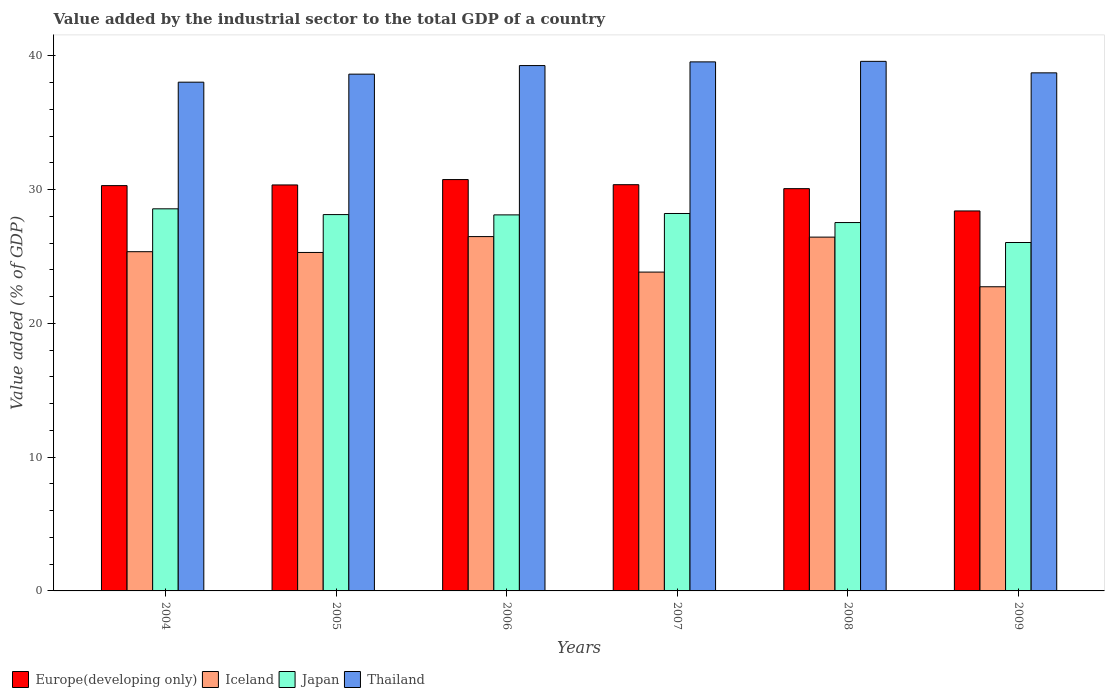How many different coloured bars are there?
Your answer should be compact. 4. How many groups of bars are there?
Provide a short and direct response. 6. Are the number of bars on each tick of the X-axis equal?
Offer a very short reply. Yes. How many bars are there on the 5th tick from the left?
Your answer should be compact. 4. How many bars are there on the 6th tick from the right?
Provide a succinct answer. 4. What is the value added by the industrial sector to the total GDP in Iceland in 2004?
Offer a terse response. 25.36. Across all years, what is the maximum value added by the industrial sector to the total GDP in Japan?
Provide a short and direct response. 28.56. Across all years, what is the minimum value added by the industrial sector to the total GDP in Thailand?
Offer a terse response. 38.03. In which year was the value added by the industrial sector to the total GDP in Iceland maximum?
Give a very brief answer. 2006. What is the total value added by the industrial sector to the total GDP in Japan in the graph?
Provide a short and direct response. 166.6. What is the difference between the value added by the industrial sector to the total GDP in Iceland in 2005 and that in 2008?
Offer a very short reply. -1.15. What is the difference between the value added by the industrial sector to the total GDP in Japan in 2008 and the value added by the industrial sector to the total GDP in Europe(developing only) in 2009?
Keep it short and to the point. -0.87. What is the average value added by the industrial sector to the total GDP in Iceland per year?
Give a very brief answer. 25.03. In the year 2004, what is the difference between the value added by the industrial sector to the total GDP in Thailand and value added by the industrial sector to the total GDP in Japan?
Give a very brief answer. 9.47. In how many years, is the value added by the industrial sector to the total GDP in Japan greater than 6 %?
Offer a terse response. 6. What is the ratio of the value added by the industrial sector to the total GDP in Thailand in 2005 to that in 2007?
Offer a terse response. 0.98. Is the value added by the industrial sector to the total GDP in Japan in 2007 less than that in 2008?
Provide a succinct answer. No. Is the difference between the value added by the industrial sector to the total GDP in Thailand in 2006 and 2008 greater than the difference between the value added by the industrial sector to the total GDP in Japan in 2006 and 2008?
Your response must be concise. No. What is the difference between the highest and the second highest value added by the industrial sector to the total GDP in Iceland?
Ensure brevity in your answer.  0.04. What is the difference between the highest and the lowest value added by the industrial sector to the total GDP in Iceland?
Provide a succinct answer. 3.75. What does the 2nd bar from the right in 2006 represents?
Your answer should be compact. Japan. Is it the case that in every year, the sum of the value added by the industrial sector to the total GDP in Thailand and value added by the industrial sector to the total GDP in Europe(developing only) is greater than the value added by the industrial sector to the total GDP in Japan?
Provide a succinct answer. Yes. How many bars are there?
Provide a short and direct response. 24. Are all the bars in the graph horizontal?
Ensure brevity in your answer.  No. How many years are there in the graph?
Offer a terse response. 6. What is the difference between two consecutive major ticks on the Y-axis?
Give a very brief answer. 10. How many legend labels are there?
Give a very brief answer. 4. What is the title of the graph?
Provide a succinct answer. Value added by the industrial sector to the total GDP of a country. What is the label or title of the X-axis?
Make the answer very short. Years. What is the label or title of the Y-axis?
Keep it short and to the point. Value added (% of GDP). What is the Value added (% of GDP) of Europe(developing only) in 2004?
Keep it short and to the point. 30.3. What is the Value added (% of GDP) of Iceland in 2004?
Your answer should be very brief. 25.36. What is the Value added (% of GDP) of Japan in 2004?
Keep it short and to the point. 28.56. What is the Value added (% of GDP) of Thailand in 2004?
Give a very brief answer. 38.03. What is the Value added (% of GDP) of Europe(developing only) in 2005?
Your answer should be compact. 30.35. What is the Value added (% of GDP) of Iceland in 2005?
Provide a succinct answer. 25.3. What is the Value added (% of GDP) of Japan in 2005?
Offer a very short reply. 28.13. What is the Value added (% of GDP) of Thailand in 2005?
Give a very brief answer. 38.63. What is the Value added (% of GDP) in Europe(developing only) in 2006?
Your answer should be very brief. 30.75. What is the Value added (% of GDP) in Iceland in 2006?
Your response must be concise. 26.49. What is the Value added (% of GDP) of Japan in 2006?
Your answer should be compact. 28.11. What is the Value added (% of GDP) in Thailand in 2006?
Your answer should be compact. 39.27. What is the Value added (% of GDP) of Europe(developing only) in 2007?
Provide a succinct answer. 30.37. What is the Value added (% of GDP) in Iceland in 2007?
Make the answer very short. 23.83. What is the Value added (% of GDP) of Japan in 2007?
Provide a short and direct response. 28.21. What is the Value added (% of GDP) of Thailand in 2007?
Provide a short and direct response. 39.55. What is the Value added (% of GDP) in Europe(developing only) in 2008?
Give a very brief answer. 30.07. What is the Value added (% of GDP) in Iceland in 2008?
Your response must be concise. 26.45. What is the Value added (% of GDP) of Japan in 2008?
Keep it short and to the point. 27.54. What is the Value added (% of GDP) in Thailand in 2008?
Your answer should be very brief. 39.59. What is the Value added (% of GDP) in Europe(developing only) in 2009?
Make the answer very short. 28.4. What is the Value added (% of GDP) of Iceland in 2009?
Your response must be concise. 22.74. What is the Value added (% of GDP) in Japan in 2009?
Ensure brevity in your answer.  26.04. What is the Value added (% of GDP) of Thailand in 2009?
Your answer should be very brief. 38.73. Across all years, what is the maximum Value added (% of GDP) in Europe(developing only)?
Give a very brief answer. 30.75. Across all years, what is the maximum Value added (% of GDP) of Iceland?
Offer a terse response. 26.49. Across all years, what is the maximum Value added (% of GDP) of Japan?
Offer a terse response. 28.56. Across all years, what is the maximum Value added (% of GDP) of Thailand?
Your answer should be compact. 39.59. Across all years, what is the minimum Value added (% of GDP) of Europe(developing only)?
Keep it short and to the point. 28.4. Across all years, what is the minimum Value added (% of GDP) of Iceland?
Offer a very short reply. 22.74. Across all years, what is the minimum Value added (% of GDP) of Japan?
Provide a succinct answer. 26.04. Across all years, what is the minimum Value added (% of GDP) of Thailand?
Provide a succinct answer. 38.03. What is the total Value added (% of GDP) in Europe(developing only) in the graph?
Provide a succinct answer. 180.23. What is the total Value added (% of GDP) of Iceland in the graph?
Your answer should be compact. 150.16. What is the total Value added (% of GDP) in Japan in the graph?
Ensure brevity in your answer.  166.6. What is the total Value added (% of GDP) in Thailand in the graph?
Make the answer very short. 233.78. What is the difference between the Value added (% of GDP) of Europe(developing only) in 2004 and that in 2005?
Offer a terse response. -0.05. What is the difference between the Value added (% of GDP) in Iceland in 2004 and that in 2005?
Ensure brevity in your answer.  0.06. What is the difference between the Value added (% of GDP) of Japan in 2004 and that in 2005?
Offer a terse response. 0.43. What is the difference between the Value added (% of GDP) of Thailand in 2004 and that in 2005?
Your response must be concise. -0.6. What is the difference between the Value added (% of GDP) in Europe(developing only) in 2004 and that in 2006?
Give a very brief answer. -0.45. What is the difference between the Value added (% of GDP) in Iceland in 2004 and that in 2006?
Provide a succinct answer. -1.13. What is the difference between the Value added (% of GDP) of Japan in 2004 and that in 2006?
Offer a terse response. 0.45. What is the difference between the Value added (% of GDP) in Thailand in 2004 and that in 2006?
Keep it short and to the point. -1.24. What is the difference between the Value added (% of GDP) of Europe(developing only) in 2004 and that in 2007?
Your answer should be compact. -0.07. What is the difference between the Value added (% of GDP) of Iceland in 2004 and that in 2007?
Your answer should be compact. 1.52. What is the difference between the Value added (% of GDP) of Japan in 2004 and that in 2007?
Provide a succinct answer. 0.35. What is the difference between the Value added (% of GDP) of Thailand in 2004 and that in 2007?
Ensure brevity in your answer.  -1.52. What is the difference between the Value added (% of GDP) of Europe(developing only) in 2004 and that in 2008?
Make the answer very short. 0.23. What is the difference between the Value added (% of GDP) in Iceland in 2004 and that in 2008?
Offer a very short reply. -1.09. What is the difference between the Value added (% of GDP) of Japan in 2004 and that in 2008?
Offer a terse response. 1.03. What is the difference between the Value added (% of GDP) of Thailand in 2004 and that in 2008?
Your answer should be very brief. -1.56. What is the difference between the Value added (% of GDP) of Europe(developing only) in 2004 and that in 2009?
Ensure brevity in your answer.  1.89. What is the difference between the Value added (% of GDP) in Iceland in 2004 and that in 2009?
Ensure brevity in your answer.  2.62. What is the difference between the Value added (% of GDP) of Japan in 2004 and that in 2009?
Your response must be concise. 2.52. What is the difference between the Value added (% of GDP) in Thailand in 2004 and that in 2009?
Make the answer very short. -0.7. What is the difference between the Value added (% of GDP) of Europe(developing only) in 2005 and that in 2006?
Give a very brief answer. -0.4. What is the difference between the Value added (% of GDP) in Iceland in 2005 and that in 2006?
Offer a terse response. -1.19. What is the difference between the Value added (% of GDP) of Japan in 2005 and that in 2006?
Your answer should be compact. 0.02. What is the difference between the Value added (% of GDP) in Thailand in 2005 and that in 2006?
Provide a succinct answer. -0.64. What is the difference between the Value added (% of GDP) of Europe(developing only) in 2005 and that in 2007?
Offer a very short reply. -0.02. What is the difference between the Value added (% of GDP) in Iceland in 2005 and that in 2007?
Ensure brevity in your answer.  1.47. What is the difference between the Value added (% of GDP) of Japan in 2005 and that in 2007?
Keep it short and to the point. -0.08. What is the difference between the Value added (% of GDP) in Thailand in 2005 and that in 2007?
Offer a very short reply. -0.92. What is the difference between the Value added (% of GDP) in Europe(developing only) in 2005 and that in 2008?
Provide a short and direct response. 0.28. What is the difference between the Value added (% of GDP) in Iceland in 2005 and that in 2008?
Give a very brief answer. -1.15. What is the difference between the Value added (% of GDP) of Japan in 2005 and that in 2008?
Offer a very short reply. 0.6. What is the difference between the Value added (% of GDP) in Thailand in 2005 and that in 2008?
Ensure brevity in your answer.  -0.96. What is the difference between the Value added (% of GDP) of Europe(developing only) in 2005 and that in 2009?
Your answer should be very brief. 1.94. What is the difference between the Value added (% of GDP) of Iceland in 2005 and that in 2009?
Your answer should be compact. 2.56. What is the difference between the Value added (% of GDP) of Japan in 2005 and that in 2009?
Your answer should be very brief. 2.09. What is the difference between the Value added (% of GDP) in Thailand in 2005 and that in 2009?
Offer a terse response. -0.1. What is the difference between the Value added (% of GDP) of Europe(developing only) in 2006 and that in 2007?
Your answer should be compact. 0.38. What is the difference between the Value added (% of GDP) of Iceland in 2006 and that in 2007?
Provide a succinct answer. 2.65. What is the difference between the Value added (% of GDP) of Japan in 2006 and that in 2007?
Provide a short and direct response. -0.1. What is the difference between the Value added (% of GDP) of Thailand in 2006 and that in 2007?
Offer a very short reply. -0.28. What is the difference between the Value added (% of GDP) of Europe(developing only) in 2006 and that in 2008?
Provide a short and direct response. 0.68. What is the difference between the Value added (% of GDP) of Iceland in 2006 and that in 2008?
Offer a terse response. 0.04. What is the difference between the Value added (% of GDP) of Japan in 2006 and that in 2008?
Keep it short and to the point. 0.57. What is the difference between the Value added (% of GDP) in Thailand in 2006 and that in 2008?
Your response must be concise. -0.32. What is the difference between the Value added (% of GDP) in Europe(developing only) in 2006 and that in 2009?
Give a very brief answer. 2.35. What is the difference between the Value added (% of GDP) of Iceland in 2006 and that in 2009?
Offer a terse response. 3.75. What is the difference between the Value added (% of GDP) in Japan in 2006 and that in 2009?
Keep it short and to the point. 2.06. What is the difference between the Value added (% of GDP) in Thailand in 2006 and that in 2009?
Offer a very short reply. 0.54. What is the difference between the Value added (% of GDP) of Europe(developing only) in 2007 and that in 2008?
Ensure brevity in your answer.  0.3. What is the difference between the Value added (% of GDP) in Iceland in 2007 and that in 2008?
Ensure brevity in your answer.  -2.61. What is the difference between the Value added (% of GDP) of Japan in 2007 and that in 2008?
Your answer should be compact. 0.68. What is the difference between the Value added (% of GDP) in Thailand in 2007 and that in 2008?
Offer a very short reply. -0.04. What is the difference between the Value added (% of GDP) in Europe(developing only) in 2007 and that in 2009?
Provide a succinct answer. 1.96. What is the difference between the Value added (% of GDP) of Iceland in 2007 and that in 2009?
Your answer should be very brief. 1.1. What is the difference between the Value added (% of GDP) of Japan in 2007 and that in 2009?
Ensure brevity in your answer.  2.17. What is the difference between the Value added (% of GDP) in Thailand in 2007 and that in 2009?
Offer a terse response. 0.82. What is the difference between the Value added (% of GDP) of Europe(developing only) in 2008 and that in 2009?
Ensure brevity in your answer.  1.67. What is the difference between the Value added (% of GDP) in Iceland in 2008 and that in 2009?
Offer a terse response. 3.71. What is the difference between the Value added (% of GDP) in Japan in 2008 and that in 2009?
Your answer should be very brief. 1.49. What is the difference between the Value added (% of GDP) of Thailand in 2008 and that in 2009?
Offer a terse response. 0.86. What is the difference between the Value added (% of GDP) of Europe(developing only) in 2004 and the Value added (% of GDP) of Iceland in 2005?
Offer a terse response. 5. What is the difference between the Value added (% of GDP) in Europe(developing only) in 2004 and the Value added (% of GDP) in Japan in 2005?
Keep it short and to the point. 2.17. What is the difference between the Value added (% of GDP) in Europe(developing only) in 2004 and the Value added (% of GDP) in Thailand in 2005?
Ensure brevity in your answer.  -8.33. What is the difference between the Value added (% of GDP) in Iceland in 2004 and the Value added (% of GDP) in Japan in 2005?
Provide a short and direct response. -2.77. What is the difference between the Value added (% of GDP) in Iceland in 2004 and the Value added (% of GDP) in Thailand in 2005?
Give a very brief answer. -13.27. What is the difference between the Value added (% of GDP) of Japan in 2004 and the Value added (% of GDP) of Thailand in 2005?
Your answer should be very brief. -10.07. What is the difference between the Value added (% of GDP) in Europe(developing only) in 2004 and the Value added (% of GDP) in Iceland in 2006?
Offer a very short reply. 3.81. What is the difference between the Value added (% of GDP) of Europe(developing only) in 2004 and the Value added (% of GDP) of Japan in 2006?
Your answer should be very brief. 2.19. What is the difference between the Value added (% of GDP) in Europe(developing only) in 2004 and the Value added (% of GDP) in Thailand in 2006?
Offer a terse response. -8.97. What is the difference between the Value added (% of GDP) of Iceland in 2004 and the Value added (% of GDP) of Japan in 2006?
Offer a terse response. -2.75. What is the difference between the Value added (% of GDP) in Iceland in 2004 and the Value added (% of GDP) in Thailand in 2006?
Your response must be concise. -13.91. What is the difference between the Value added (% of GDP) of Japan in 2004 and the Value added (% of GDP) of Thailand in 2006?
Give a very brief answer. -10.71. What is the difference between the Value added (% of GDP) of Europe(developing only) in 2004 and the Value added (% of GDP) of Iceland in 2007?
Give a very brief answer. 6.46. What is the difference between the Value added (% of GDP) of Europe(developing only) in 2004 and the Value added (% of GDP) of Japan in 2007?
Keep it short and to the point. 2.08. What is the difference between the Value added (% of GDP) in Europe(developing only) in 2004 and the Value added (% of GDP) in Thailand in 2007?
Provide a succinct answer. -9.25. What is the difference between the Value added (% of GDP) of Iceland in 2004 and the Value added (% of GDP) of Japan in 2007?
Make the answer very short. -2.86. What is the difference between the Value added (% of GDP) of Iceland in 2004 and the Value added (% of GDP) of Thailand in 2007?
Give a very brief answer. -14.19. What is the difference between the Value added (% of GDP) of Japan in 2004 and the Value added (% of GDP) of Thailand in 2007?
Your answer should be very brief. -10.98. What is the difference between the Value added (% of GDP) in Europe(developing only) in 2004 and the Value added (% of GDP) in Iceland in 2008?
Your answer should be very brief. 3.85. What is the difference between the Value added (% of GDP) in Europe(developing only) in 2004 and the Value added (% of GDP) in Japan in 2008?
Your answer should be very brief. 2.76. What is the difference between the Value added (% of GDP) in Europe(developing only) in 2004 and the Value added (% of GDP) in Thailand in 2008?
Your answer should be compact. -9.29. What is the difference between the Value added (% of GDP) of Iceland in 2004 and the Value added (% of GDP) of Japan in 2008?
Offer a terse response. -2.18. What is the difference between the Value added (% of GDP) of Iceland in 2004 and the Value added (% of GDP) of Thailand in 2008?
Ensure brevity in your answer.  -14.23. What is the difference between the Value added (% of GDP) in Japan in 2004 and the Value added (% of GDP) in Thailand in 2008?
Make the answer very short. -11.02. What is the difference between the Value added (% of GDP) of Europe(developing only) in 2004 and the Value added (% of GDP) of Iceland in 2009?
Offer a very short reply. 7.56. What is the difference between the Value added (% of GDP) in Europe(developing only) in 2004 and the Value added (% of GDP) in Japan in 2009?
Make the answer very short. 4.25. What is the difference between the Value added (% of GDP) in Europe(developing only) in 2004 and the Value added (% of GDP) in Thailand in 2009?
Offer a terse response. -8.43. What is the difference between the Value added (% of GDP) of Iceland in 2004 and the Value added (% of GDP) of Japan in 2009?
Give a very brief answer. -0.69. What is the difference between the Value added (% of GDP) of Iceland in 2004 and the Value added (% of GDP) of Thailand in 2009?
Your answer should be compact. -13.37. What is the difference between the Value added (% of GDP) in Japan in 2004 and the Value added (% of GDP) in Thailand in 2009?
Keep it short and to the point. -10.16. What is the difference between the Value added (% of GDP) of Europe(developing only) in 2005 and the Value added (% of GDP) of Iceland in 2006?
Give a very brief answer. 3.86. What is the difference between the Value added (% of GDP) in Europe(developing only) in 2005 and the Value added (% of GDP) in Japan in 2006?
Ensure brevity in your answer.  2.24. What is the difference between the Value added (% of GDP) in Europe(developing only) in 2005 and the Value added (% of GDP) in Thailand in 2006?
Your answer should be very brief. -8.92. What is the difference between the Value added (% of GDP) in Iceland in 2005 and the Value added (% of GDP) in Japan in 2006?
Provide a short and direct response. -2.81. What is the difference between the Value added (% of GDP) of Iceland in 2005 and the Value added (% of GDP) of Thailand in 2006?
Keep it short and to the point. -13.97. What is the difference between the Value added (% of GDP) in Japan in 2005 and the Value added (% of GDP) in Thailand in 2006?
Offer a terse response. -11.14. What is the difference between the Value added (% of GDP) in Europe(developing only) in 2005 and the Value added (% of GDP) in Iceland in 2007?
Make the answer very short. 6.51. What is the difference between the Value added (% of GDP) of Europe(developing only) in 2005 and the Value added (% of GDP) of Japan in 2007?
Ensure brevity in your answer.  2.13. What is the difference between the Value added (% of GDP) in Europe(developing only) in 2005 and the Value added (% of GDP) in Thailand in 2007?
Offer a very short reply. -9.2. What is the difference between the Value added (% of GDP) in Iceland in 2005 and the Value added (% of GDP) in Japan in 2007?
Provide a short and direct response. -2.91. What is the difference between the Value added (% of GDP) of Iceland in 2005 and the Value added (% of GDP) of Thailand in 2007?
Keep it short and to the point. -14.25. What is the difference between the Value added (% of GDP) of Japan in 2005 and the Value added (% of GDP) of Thailand in 2007?
Provide a succinct answer. -11.41. What is the difference between the Value added (% of GDP) of Europe(developing only) in 2005 and the Value added (% of GDP) of Iceland in 2008?
Give a very brief answer. 3.9. What is the difference between the Value added (% of GDP) in Europe(developing only) in 2005 and the Value added (% of GDP) in Japan in 2008?
Provide a succinct answer. 2.81. What is the difference between the Value added (% of GDP) of Europe(developing only) in 2005 and the Value added (% of GDP) of Thailand in 2008?
Your answer should be compact. -9.24. What is the difference between the Value added (% of GDP) in Iceland in 2005 and the Value added (% of GDP) in Japan in 2008?
Keep it short and to the point. -2.24. What is the difference between the Value added (% of GDP) of Iceland in 2005 and the Value added (% of GDP) of Thailand in 2008?
Provide a short and direct response. -14.29. What is the difference between the Value added (% of GDP) in Japan in 2005 and the Value added (% of GDP) in Thailand in 2008?
Keep it short and to the point. -11.45. What is the difference between the Value added (% of GDP) of Europe(developing only) in 2005 and the Value added (% of GDP) of Iceland in 2009?
Keep it short and to the point. 7.61. What is the difference between the Value added (% of GDP) in Europe(developing only) in 2005 and the Value added (% of GDP) in Japan in 2009?
Your response must be concise. 4.3. What is the difference between the Value added (% of GDP) of Europe(developing only) in 2005 and the Value added (% of GDP) of Thailand in 2009?
Provide a succinct answer. -8.38. What is the difference between the Value added (% of GDP) in Iceland in 2005 and the Value added (% of GDP) in Japan in 2009?
Your answer should be compact. -0.74. What is the difference between the Value added (% of GDP) of Iceland in 2005 and the Value added (% of GDP) of Thailand in 2009?
Your answer should be very brief. -13.43. What is the difference between the Value added (% of GDP) in Japan in 2005 and the Value added (% of GDP) in Thailand in 2009?
Make the answer very short. -10.59. What is the difference between the Value added (% of GDP) of Europe(developing only) in 2006 and the Value added (% of GDP) of Iceland in 2007?
Give a very brief answer. 6.92. What is the difference between the Value added (% of GDP) in Europe(developing only) in 2006 and the Value added (% of GDP) in Japan in 2007?
Offer a terse response. 2.54. What is the difference between the Value added (% of GDP) of Europe(developing only) in 2006 and the Value added (% of GDP) of Thailand in 2007?
Ensure brevity in your answer.  -8.8. What is the difference between the Value added (% of GDP) in Iceland in 2006 and the Value added (% of GDP) in Japan in 2007?
Your response must be concise. -1.73. What is the difference between the Value added (% of GDP) in Iceland in 2006 and the Value added (% of GDP) in Thailand in 2007?
Your answer should be compact. -13.06. What is the difference between the Value added (% of GDP) in Japan in 2006 and the Value added (% of GDP) in Thailand in 2007?
Your answer should be compact. -11.44. What is the difference between the Value added (% of GDP) in Europe(developing only) in 2006 and the Value added (% of GDP) in Iceland in 2008?
Offer a terse response. 4.3. What is the difference between the Value added (% of GDP) of Europe(developing only) in 2006 and the Value added (% of GDP) of Japan in 2008?
Provide a short and direct response. 3.21. What is the difference between the Value added (% of GDP) of Europe(developing only) in 2006 and the Value added (% of GDP) of Thailand in 2008?
Your answer should be very brief. -8.84. What is the difference between the Value added (% of GDP) in Iceland in 2006 and the Value added (% of GDP) in Japan in 2008?
Ensure brevity in your answer.  -1.05. What is the difference between the Value added (% of GDP) in Iceland in 2006 and the Value added (% of GDP) in Thailand in 2008?
Keep it short and to the point. -13.1. What is the difference between the Value added (% of GDP) in Japan in 2006 and the Value added (% of GDP) in Thailand in 2008?
Your answer should be very brief. -11.48. What is the difference between the Value added (% of GDP) of Europe(developing only) in 2006 and the Value added (% of GDP) of Iceland in 2009?
Offer a very short reply. 8.01. What is the difference between the Value added (% of GDP) of Europe(developing only) in 2006 and the Value added (% of GDP) of Japan in 2009?
Offer a terse response. 4.7. What is the difference between the Value added (% of GDP) in Europe(developing only) in 2006 and the Value added (% of GDP) in Thailand in 2009?
Ensure brevity in your answer.  -7.98. What is the difference between the Value added (% of GDP) in Iceland in 2006 and the Value added (% of GDP) in Japan in 2009?
Provide a short and direct response. 0.44. What is the difference between the Value added (% of GDP) of Iceland in 2006 and the Value added (% of GDP) of Thailand in 2009?
Offer a terse response. -12.24. What is the difference between the Value added (% of GDP) of Japan in 2006 and the Value added (% of GDP) of Thailand in 2009?
Offer a terse response. -10.62. What is the difference between the Value added (% of GDP) of Europe(developing only) in 2007 and the Value added (% of GDP) of Iceland in 2008?
Provide a succinct answer. 3.92. What is the difference between the Value added (% of GDP) in Europe(developing only) in 2007 and the Value added (% of GDP) in Japan in 2008?
Offer a terse response. 2.83. What is the difference between the Value added (% of GDP) of Europe(developing only) in 2007 and the Value added (% of GDP) of Thailand in 2008?
Give a very brief answer. -9.22. What is the difference between the Value added (% of GDP) in Iceland in 2007 and the Value added (% of GDP) in Japan in 2008?
Provide a succinct answer. -3.7. What is the difference between the Value added (% of GDP) in Iceland in 2007 and the Value added (% of GDP) in Thailand in 2008?
Your response must be concise. -15.75. What is the difference between the Value added (% of GDP) of Japan in 2007 and the Value added (% of GDP) of Thailand in 2008?
Offer a terse response. -11.37. What is the difference between the Value added (% of GDP) of Europe(developing only) in 2007 and the Value added (% of GDP) of Iceland in 2009?
Offer a terse response. 7.63. What is the difference between the Value added (% of GDP) in Europe(developing only) in 2007 and the Value added (% of GDP) in Japan in 2009?
Ensure brevity in your answer.  4.32. What is the difference between the Value added (% of GDP) in Europe(developing only) in 2007 and the Value added (% of GDP) in Thailand in 2009?
Your answer should be compact. -8.36. What is the difference between the Value added (% of GDP) in Iceland in 2007 and the Value added (% of GDP) in Japan in 2009?
Your answer should be very brief. -2.21. What is the difference between the Value added (% of GDP) in Iceland in 2007 and the Value added (% of GDP) in Thailand in 2009?
Offer a terse response. -14.89. What is the difference between the Value added (% of GDP) in Japan in 2007 and the Value added (% of GDP) in Thailand in 2009?
Keep it short and to the point. -10.51. What is the difference between the Value added (% of GDP) of Europe(developing only) in 2008 and the Value added (% of GDP) of Iceland in 2009?
Offer a very short reply. 7.33. What is the difference between the Value added (% of GDP) in Europe(developing only) in 2008 and the Value added (% of GDP) in Japan in 2009?
Offer a terse response. 4.03. What is the difference between the Value added (% of GDP) in Europe(developing only) in 2008 and the Value added (% of GDP) in Thailand in 2009?
Make the answer very short. -8.66. What is the difference between the Value added (% of GDP) in Iceland in 2008 and the Value added (% of GDP) in Japan in 2009?
Ensure brevity in your answer.  0.4. What is the difference between the Value added (% of GDP) of Iceland in 2008 and the Value added (% of GDP) of Thailand in 2009?
Make the answer very short. -12.28. What is the difference between the Value added (% of GDP) in Japan in 2008 and the Value added (% of GDP) in Thailand in 2009?
Ensure brevity in your answer.  -11.19. What is the average Value added (% of GDP) of Europe(developing only) per year?
Your response must be concise. 30.04. What is the average Value added (% of GDP) in Iceland per year?
Your answer should be compact. 25.03. What is the average Value added (% of GDP) of Japan per year?
Your answer should be very brief. 27.77. What is the average Value added (% of GDP) of Thailand per year?
Provide a short and direct response. 38.96. In the year 2004, what is the difference between the Value added (% of GDP) of Europe(developing only) and Value added (% of GDP) of Iceland?
Ensure brevity in your answer.  4.94. In the year 2004, what is the difference between the Value added (% of GDP) of Europe(developing only) and Value added (% of GDP) of Japan?
Offer a very short reply. 1.73. In the year 2004, what is the difference between the Value added (% of GDP) in Europe(developing only) and Value added (% of GDP) in Thailand?
Your answer should be very brief. -7.73. In the year 2004, what is the difference between the Value added (% of GDP) of Iceland and Value added (% of GDP) of Japan?
Provide a short and direct response. -3.21. In the year 2004, what is the difference between the Value added (% of GDP) in Iceland and Value added (% of GDP) in Thailand?
Provide a short and direct response. -12.67. In the year 2004, what is the difference between the Value added (% of GDP) of Japan and Value added (% of GDP) of Thailand?
Make the answer very short. -9.47. In the year 2005, what is the difference between the Value added (% of GDP) in Europe(developing only) and Value added (% of GDP) in Iceland?
Provide a short and direct response. 5.05. In the year 2005, what is the difference between the Value added (% of GDP) in Europe(developing only) and Value added (% of GDP) in Japan?
Your answer should be very brief. 2.22. In the year 2005, what is the difference between the Value added (% of GDP) in Europe(developing only) and Value added (% of GDP) in Thailand?
Ensure brevity in your answer.  -8.28. In the year 2005, what is the difference between the Value added (% of GDP) of Iceland and Value added (% of GDP) of Japan?
Provide a succinct answer. -2.83. In the year 2005, what is the difference between the Value added (% of GDP) of Iceland and Value added (% of GDP) of Thailand?
Provide a short and direct response. -13.33. In the year 2005, what is the difference between the Value added (% of GDP) in Japan and Value added (% of GDP) in Thailand?
Your answer should be very brief. -10.5. In the year 2006, what is the difference between the Value added (% of GDP) in Europe(developing only) and Value added (% of GDP) in Iceland?
Your response must be concise. 4.26. In the year 2006, what is the difference between the Value added (% of GDP) in Europe(developing only) and Value added (% of GDP) in Japan?
Offer a terse response. 2.64. In the year 2006, what is the difference between the Value added (% of GDP) of Europe(developing only) and Value added (% of GDP) of Thailand?
Make the answer very short. -8.52. In the year 2006, what is the difference between the Value added (% of GDP) of Iceland and Value added (% of GDP) of Japan?
Keep it short and to the point. -1.62. In the year 2006, what is the difference between the Value added (% of GDP) in Iceland and Value added (% of GDP) in Thailand?
Make the answer very short. -12.78. In the year 2006, what is the difference between the Value added (% of GDP) in Japan and Value added (% of GDP) in Thailand?
Offer a very short reply. -11.16. In the year 2007, what is the difference between the Value added (% of GDP) of Europe(developing only) and Value added (% of GDP) of Iceland?
Offer a terse response. 6.53. In the year 2007, what is the difference between the Value added (% of GDP) of Europe(developing only) and Value added (% of GDP) of Japan?
Make the answer very short. 2.15. In the year 2007, what is the difference between the Value added (% of GDP) in Europe(developing only) and Value added (% of GDP) in Thailand?
Ensure brevity in your answer.  -9.18. In the year 2007, what is the difference between the Value added (% of GDP) in Iceland and Value added (% of GDP) in Japan?
Offer a very short reply. -4.38. In the year 2007, what is the difference between the Value added (% of GDP) of Iceland and Value added (% of GDP) of Thailand?
Provide a short and direct response. -15.71. In the year 2007, what is the difference between the Value added (% of GDP) of Japan and Value added (% of GDP) of Thailand?
Keep it short and to the point. -11.33. In the year 2008, what is the difference between the Value added (% of GDP) in Europe(developing only) and Value added (% of GDP) in Iceland?
Ensure brevity in your answer.  3.62. In the year 2008, what is the difference between the Value added (% of GDP) in Europe(developing only) and Value added (% of GDP) in Japan?
Your answer should be very brief. 2.53. In the year 2008, what is the difference between the Value added (% of GDP) of Europe(developing only) and Value added (% of GDP) of Thailand?
Keep it short and to the point. -9.52. In the year 2008, what is the difference between the Value added (% of GDP) of Iceland and Value added (% of GDP) of Japan?
Offer a very short reply. -1.09. In the year 2008, what is the difference between the Value added (% of GDP) of Iceland and Value added (% of GDP) of Thailand?
Offer a terse response. -13.14. In the year 2008, what is the difference between the Value added (% of GDP) in Japan and Value added (% of GDP) in Thailand?
Your answer should be compact. -12.05. In the year 2009, what is the difference between the Value added (% of GDP) of Europe(developing only) and Value added (% of GDP) of Iceland?
Provide a succinct answer. 5.67. In the year 2009, what is the difference between the Value added (% of GDP) in Europe(developing only) and Value added (% of GDP) in Japan?
Make the answer very short. 2.36. In the year 2009, what is the difference between the Value added (% of GDP) of Europe(developing only) and Value added (% of GDP) of Thailand?
Provide a short and direct response. -10.32. In the year 2009, what is the difference between the Value added (% of GDP) of Iceland and Value added (% of GDP) of Japan?
Offer a terse response. -3.31. In the year 2009, what is the difference between the Value added (% of GDP) in Iceland and Value added (% of GDP) in Thailand?
Your answer should be very brief. -15.99. In the year 2009, what is the difference between the Value added (% of GDP) of Japan and Value added (% of GDP) of Thailand?
Provide a short and direct response. -12.68. What is the ratio of the Value added (% of GDP) of Japan in 2004 to that in 2005?
Offer a very short reply. 1.02. What is the ratio of the Value added (% of GDP) in Thailand in 2004 to that in 2005?
Ensure brevity in your answer.  0.98. What is the ratio of the Value added (% of GDP) of Iceland in 2004 to that in 2006?
Your response must be concise. 0.96. What is the ratio of the Value added (% of GDP) in Japan in 2004 to that in 2006?
Provide a succinct answer. 1.02. What is the ratio of the Value added (% of GDP) of Thailand in 2004 to that in 2006?
Offer a terse response. 0.97. What is the ratio of the Value added (% of GDP) in Europe(developing only) in 2004 to that in 2007?
Ensure brevity in your answer.  1. What is the ratio of the Value added (% of GDP) in Iceland in 2004 to that in 2007?
Your answer should be compact. 1.06. What is the ratio of the Value added (% of GDP) of Japan in 2004 to that in 2007?
Your answer should be compact. 1.01. What is the ratio of the Value added (% of GDP) of Thailand in 2004 to that in 2007?
Keep it short and to the point. 0.96. What is the ratio of the Value added (% of GDP) of Europe(developing only) in 2004 to that in 2008?
Offer a very short reply. 1.01. What is the ratio of the Value added (% of GDP) in Iceland in 2004 to that in 2008?
Provide a short and direct response. 0.96. What is the ratio of the Value added (% of GDP) in Japan in 2004 to that in 2008?
Your answer should be very brief. 1.04. What is the ratio of the Value added (% of GDP) in Thailand in 2004 to that in 2008?
Your answer should be very brief. 0.96. What is the ratio of the Value added (% of GDP) in Europe(developing only) in 2004 to that in 2009?
Give a very brief answer. 1.07. What is the ratio of the Value added (% of GDP) of Iceland in 2004 to that in 2009?
Your answer should be very brief. 1.12. What is the ratio of the Value added (% of GDP) in Japan in 2004 to that in 2009?
Your answer should be very brief. 1.1. What is the ratio of the Value added (% of GDP) in Thailand in 2004 to that in 2009?
Offer a very short reply. 0.98. What is the ratio of the Value added (% of GDP) in Europe(developing only) in 2005 to that in 2006?
Offer a terse response. 0.99. What is the ratio of the Value added (% of GDP) of Iceland in 2005 to that in 2006?
Give a very brief answer. 0.96. What is the ratio of the Value added (% of GDP) in Japan in 2005 to that in 2006?
Provide a succinct answer. 1. What is the ratio of the Value added (% of GDP) of Thailand in 2005 to that in 2006?
Keep it short and to the point. 0.98. What is the ratio of the Value added (% of GDP) in Iceland in 2005 to that in 2007?
Offer a very short reply. 1.06. What is the ratio of the Value added (% of GDP) of Japan in 2005 to that in 2007?
Offer a terse response. 1. What is the ratio of the Value added (% of GDP) in Thailand in 2005 to that in 2007?
Ensure brevity in your answer.  0.98. What is the ratio of the Value added (% of GDP) of Europe(developing only) in 2005 to that in 2008?
Your response must be concise. 1.01. What is the ratio of the Value added (% of GDP) of Iceland in 2005 to that in 2008?
Ensure brevity in your answer.  0.96. What is the ratio of the Value added (% of GDP) of Japan in 2005 to that in 2008?
Give a very brief answer. 1.02. What is the ratio of the Value added (% of GDP) in Thailand in 2005 to that in 2008?
Your response must be concise. 0.98. What is the ratio of the Value added (% of GDP) of Europe(developing only) in 2005 to that in 2009?
Offer a terse response. 1.07. What is the ratio of the Value added (% of GDP) in Iceland in 2005 to that in 2009?
Keep it short and to the point. 1.11. What is the ratio of the Value added (% of GDP) of Japan in 2005 to that in 2009?
Your answer should be compact. 1.08. What is the ratio of the Value added (% of GDP) in Thailand in 2005 to that in 2009?
Ensure brevity in your answer.  1. What is the ratio of the Value added (% of GDP) in Europe(developing only) in 2006 to that in 2007?
Keep it short and to the point. 1.01. What is the ratio of the Value added (% of GDP) of Iceland in 2006 to that in 2007?
Provide a short and direct response. 1.11. What is the ratio of the Value added (% of GDP) in Thailand in 2006 to that in 2007?
Ensure brevity in your answer.  0.99. What is the ratio of the Value added (% of GDP) of Europe(developing only) in 2006 to that in 2008?
Your response must be concise. 1.02. What is the ratio of the Value added (% of GDP) in Japan in 2006 to that in 2008?
Keep it short and to the point. 1.02. What is the ratio of the Value added (% of GDP) of Thailand in 2006 to that in 2008?
Provide a short and direct response. 0.99. What is the ratio of the Value added (% of GDP) of Europe(developing only) in 2006 to that in 2009?
Your response must be concise. 1.08. What is the ratio of the Value added (% of GDP) in Iceland in 2006 to that in 2009?
Ensure brevity in your answer.  1.17. What is the ratio of the Value added (% of GDP) in Japan in 2006 to that in 2009?
Make the answer very short. 1.08. What is the ratio of the Value added (% of GDP) of Europe(developing only) in 2007 to that in 2008?
Make the answer very short. 1.01. What is the ratio of the Value added (% of GDP) in Iceland in 2007 to that in 2008?
Your answer should be very brief. 0.9. What is the ratio of the Value added (% of GDP) of Japan in 2007 to that in 2008?
Keep it short and to the point. 1.02. What is the ratio of the Value added (% of GDP) of Europe(developing only) in 2007 to that in 2009?
Provide a succinct answer. 1.07. What is the ratio of the Value added (% of GDP) of Iceland in 2007 to that in 2009?
Your response must be concise. 1.05. What is the ratio of the Value added (% of GDP) in Thailand in 2007 to that in 2009?
Give a very brief answer. 1.02. What is the ratio of the Value added (% of GDP) of Europe(developing only) in 2008 to that in 2009?
Provide a succinct answer. 1.06. What is the ratio of the Value added (% of GDP) in Iceland in 2008 to that in 2009?
Your response must be concise. 1.16. What is the ratio of the Value added (% of GDP) of Japan in 2008 to that in 2009?
Keep it short and to the point. 1.06. What is the ratio of the Value added (% of GDP) of Thailand in 2008 to that in 2009?
Offer a very short reply. 1.02. What is the difference between the highest and the second highest Value added (% of GDP) of Europe(developing only)?
Your answer should be very brief. 0.38. What is the difference between the highest and the second highest Value added (% of GDP) of Iceland?
Offer a terse response. 0.04. What is the difference between the highest and the second highest Value added (% of GDP) in Japan?
Give a very brief answer. 0.35. What is the difference between the highest and the second highest Value added (% of GDP) in Thailand?
Provide a succinct answer. 0.04. What is the difference between the highest and the lowest Value added (% of GDP) of Europe(developing only)?
Your response must be concise. 2.35. What is the difference between the highest and the lowest Value added (% of GDP) of Iceland?
Your answer should be very brief. 3.75. What is the difference between the highest and the lowest Value added (% of GDP) in Japan?
Keep it short and to the point. 2.52. What is the difference between the highest and the lowest Value added (% of GDP) of Thailand?
Ensure brevity in your answer.  1.56. 